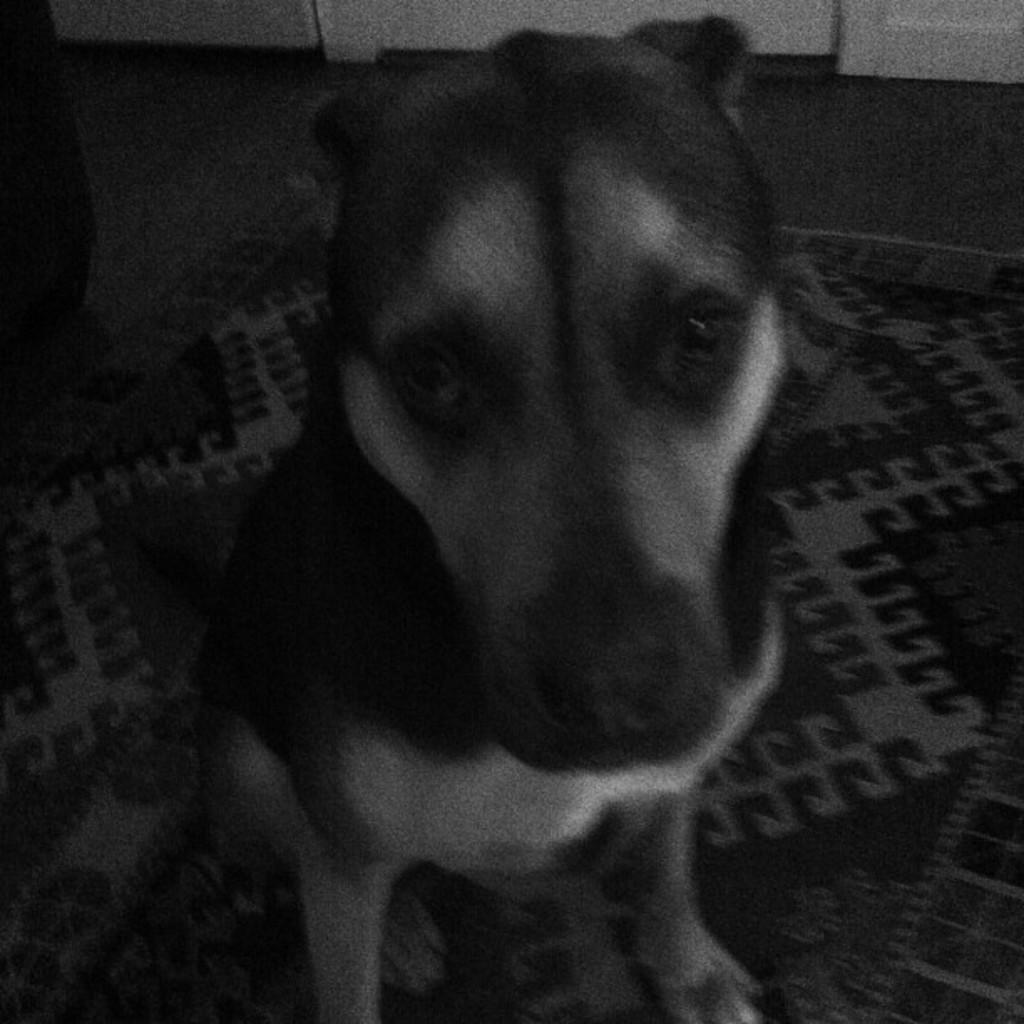Can you describe this image briefly? This is a black and white image, in this image there is a dog sitting on a mat. 